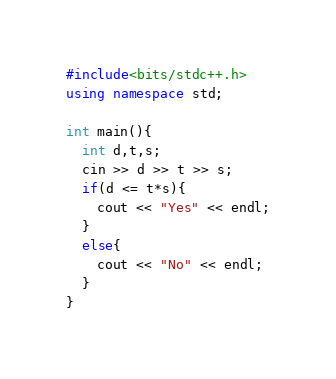<code> <loc_0><loc_0><loc_500><loc_500><_C++_>#include<bits/stdc++.h>
using namespace std;

int main(){
  int d,t,s;
  cin >> d >> t >> s;
  if(d <= t*s){
    cout << "Yes" << endl;
  }
  else{
    cout << "No" << endl;
  }
}</code> 